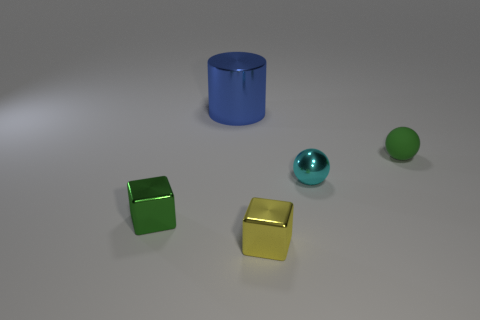Do the blue thing and the shiny thing to the left of the large cylinder have the same shape?
Your answer should be compact. No. Are there any cylinders right of the metallic sphere?
Offer a terse response. No. There is a block that is the same color as the small matte object; what material is it?
Your answer should be very brief. Metal. What number of blocks are small yellow things or tiny cyan metallic things?
Provide a succinct answer. 1. Do the blue shiny object and the yellow shiny object have the same shape?
Your answer should be very brief. No. How big is the metallic thing that is left of the big metal object?
Keep it short and to the point. Small. Is there a metallic object that has the same color as the matte sphere?
Provide a succinct answer. Yes. Is the size of the object that is right of the metal sphere the same as the big blue object?
Your answer should be very brief. No. The rubber object has what color?
Offer a terse response. Green. What color is the small metallic thing that is behind the small cube on the left side of the big blue metallic cylinder?
Offer a very short reply. Cyan. 